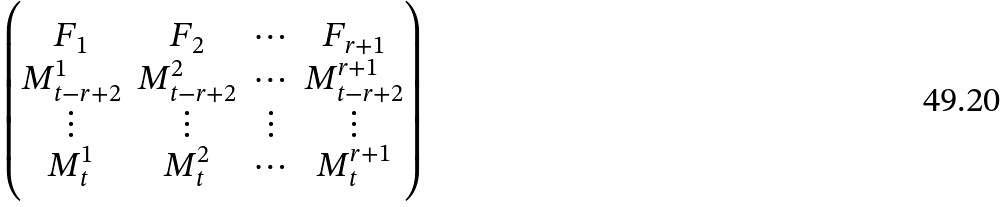<formula> <loc_0><loc_0><loc_500><loc_500>\begin{pmatrix} F _ { 1 } & F _ { 2 } & \cdots & F _ { r + 1 } \\ M _ { t - r + 2 } ^ { 1 } & M _ { t - r + 2 } ^ { 2 } & \cdots & M _ { t - r + 2 } ^ { r + 1 } \\ \vdots & \vdots & \vdots & \vdots \\ M _ { t } ^ { 1 } & M _ { t } ^ { 2 } & \cdots & M _ { t } ^ { r + 1 } \\ \end{pmatrix}</formula> 